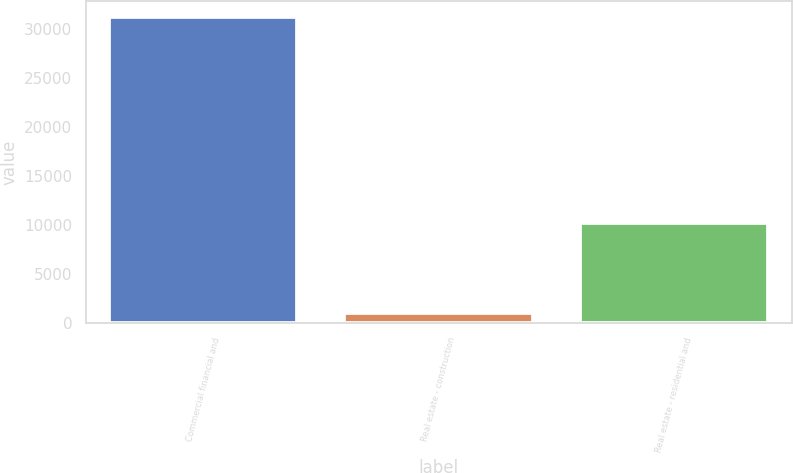<chart> <loc_0><loc_0><loc_500><loc_500><bar_chart><fcel>Commercial financial and<fcel>Real estate - construction<fcel>Real estate - residential and<nl><fcel>31240<fcel>1053<fcel>10201<nl></chart> 